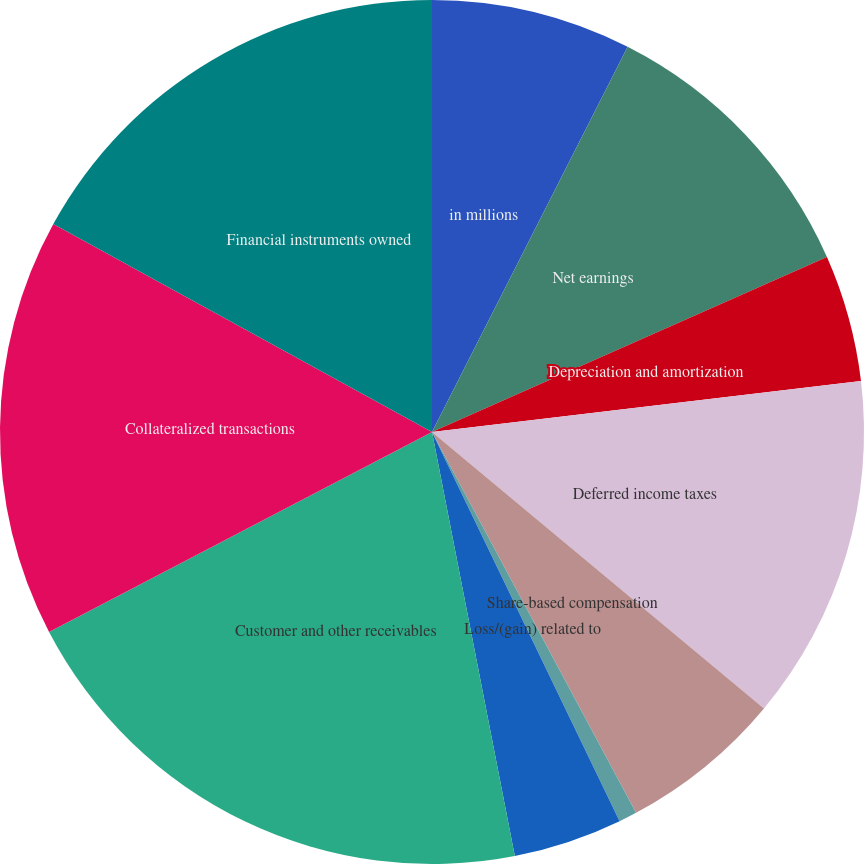<chart> <loc_0><loc_0><loc_500><loc_500><pie_chart><fcel>in millions<fcel>Net earnings<fcel>Depreciation and amortization<fcel>Deferred income taxes<fcel>Share-based compensation<fcel>Loss/(gain) related to<fcel>Provision for credit losses<fcel>Customer and other receivables<fcel>Collateralized transactions<fcel>Financial instruments owned<nl><fcel>7.48%<fcel>10.88%<fcel>4.76%<fcel>12.93%<fcel>6.12%<fcel>0.68%<fcel>4.08%<fcel>20.41%<fcel>15.65%<fcel>17.01%<nl></chart> 